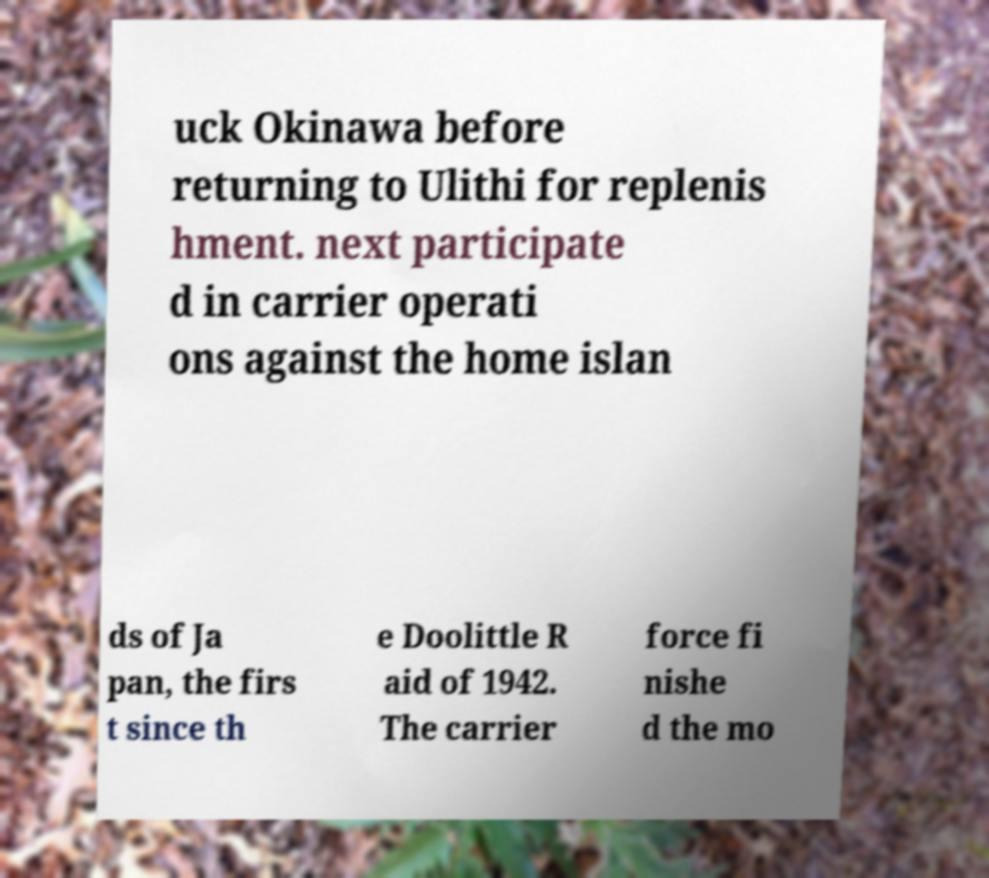Please read and relay the text visible in this image. What does it say? uck Okinawa before returning to Ulithi for replenis hment. next participate d in carrier operati ons against the home islan ds of Ja pan, the firs t since th e Doolittle R aid of 1942. The carrier force fi nishe d the mo 